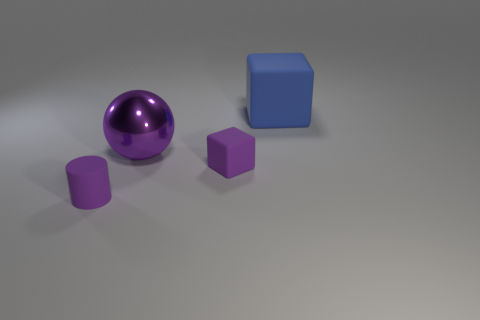There is a tiny object that is left of the small purple rubber cube; what is its shape?
Ensure brevity in your answer.  Cylinder. Are the cylinder and the block behind the tiny purple rubber cube made of the same material?
Offer a very short reply. Yes. Is the shape of the large blue matte object the same as the large purple object?
Provide a short and direct response. No. There is another small thing that is the same shape as the blue object; what is it made of?
Your answer should be compact. Rubber. There is a matte thing that is both right of the purple cylinder and on the left side of the blue rubber thing; what color is it?
Your answer should be compact. Purple. What color is the large ball?
Give a very brief answer. Purple. What material is the tiny cube that is the same color as the large shiny thing?
Keep it short and to the point. Rubber. Is there a large brown matte thing of the same shape as the blue matte object?
Make the answer very short. No. How big is the cube in front of the blue thing?
Your answer should be compact. Small. What is the material of the cylinder that is the same size as the purple matte block?
Offer a terse response. Rubber. 